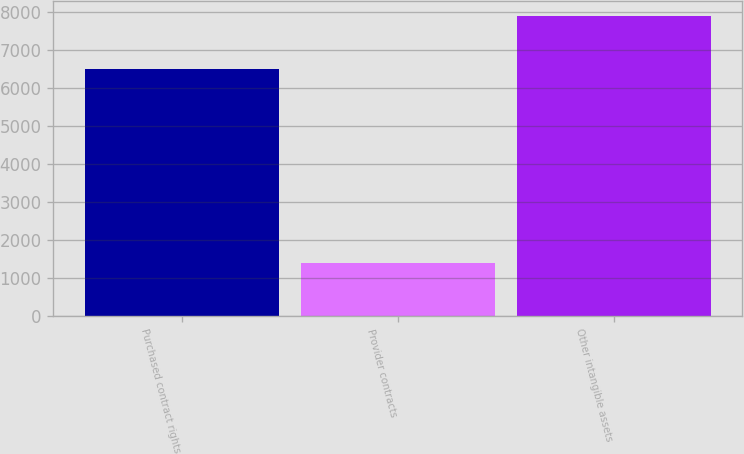Convert chart to OTSL. <chart><loc_0><loc_0><loc_500><loc_500><bar_chart><fcel>Purchased contract rights<fcel>Provider contracts<fcel>Other intangible assets<nl><fcel>6492<fcel>1400<fcel>7892<nl></chart> 